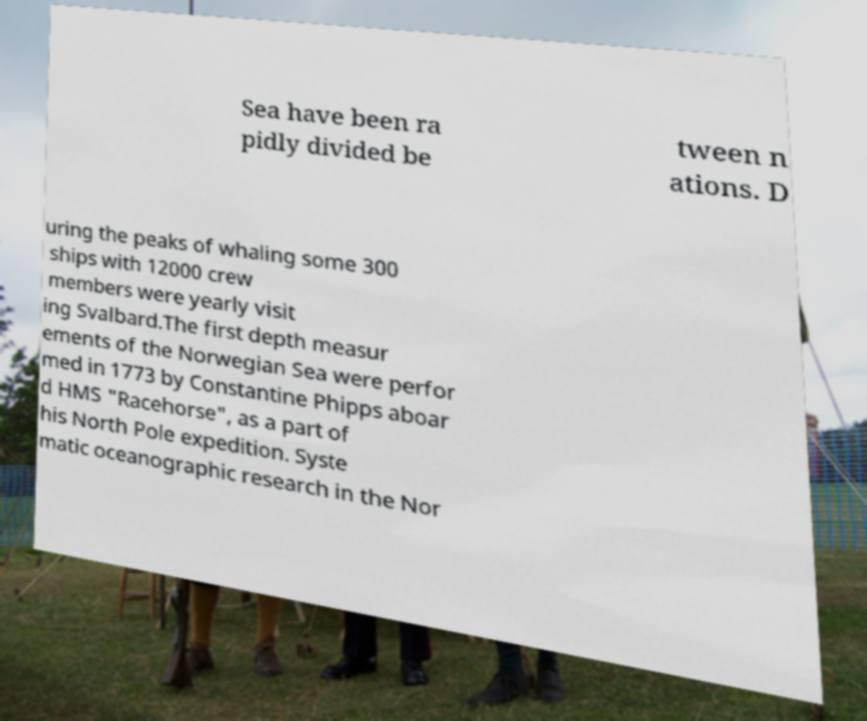Could you extract and type out the text from this image? Sea have been ra pidly divided be tween n ations. D uring the peaks of whaling some 300 ships with 12000 crew members were yearly visit ing Svalbard.The first depth measur ements of the Norwegian Sea were perfor med in 1773 by Constantine Phipps aboar d HMS "Racehorse", as a part of his North Pole expedition. Syste matic oceanographic research in the Nor 